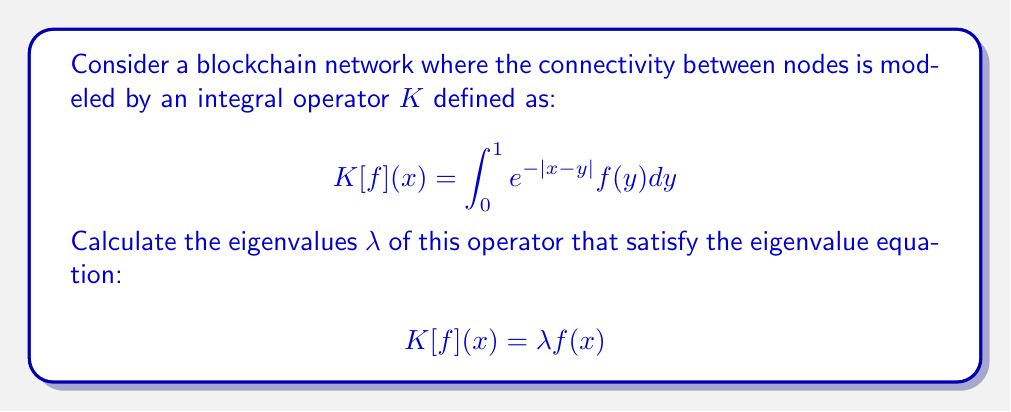Can you answer this question? To find the eigenvalues, we'll follow these steps:

1) The eigenvalue equation is:
   $$\int_0^1 e^{-|x-y|}f(y)dy = \lambda f(x)$$

2) Differentiate both sides twice with respect to x:
   $$\frac{d^2}{dx^2}\int_0^1 e^{-|x-y|}f(y)dy = \lambda \frac{d^2f}{dx^2}$$

3) The left-hand side simplifies to:
   $$\int_0^1 \frac{d^2}{dx^2}e^{-|x-y|}f(y)dy = \int_0^1 f(y)dy - f(x) = \lambda \frac{d^2f}{dx^2}$$

4) Combining this with the original equation:
   $$f(x) - \lambda \frac{d^2f}{dx^2} = \frac{1}{\lambda}f(x)$$

5) Rearranging:
   $$\frac{d^2f}{dx^2} = \frac{1-\frac{1}{\lambda}}{\lambda}f(x) = \omega^2f(x)$$
   where $\omega^2 = \frac{1-\frac{1}{\lambda}}{\lambda}$

6) The general solution is:
   $$f(x) = A\cos(\omega x) + B\sin(\omega x)$$

7) Apply boundary conditions $f'(0) = f(0)$ and $f'(1) = -f(1)$:
   $$B\omega = A$$
   $$-A\omega\sin(\omega) + B\omega\cos(\omega) = -(A\cos(\omega) + B\sin(\omega))$$

8) For non-trivial solutions, the determinant must be zero:
   $$\omega(\cos(\omega) + \sin(\omega)) = 1$$

9) Solve this transcendental equation numerically to find $\omega$, then use:
   $$\lambda = \frac{1}{1-\omega^2}$$
Answer: $\lambda = \frac{1}{1-\omega^2}$, where $\omega$ satisfies $\omega(\cos(\omega) + \sin(\omega)) = 1$ 